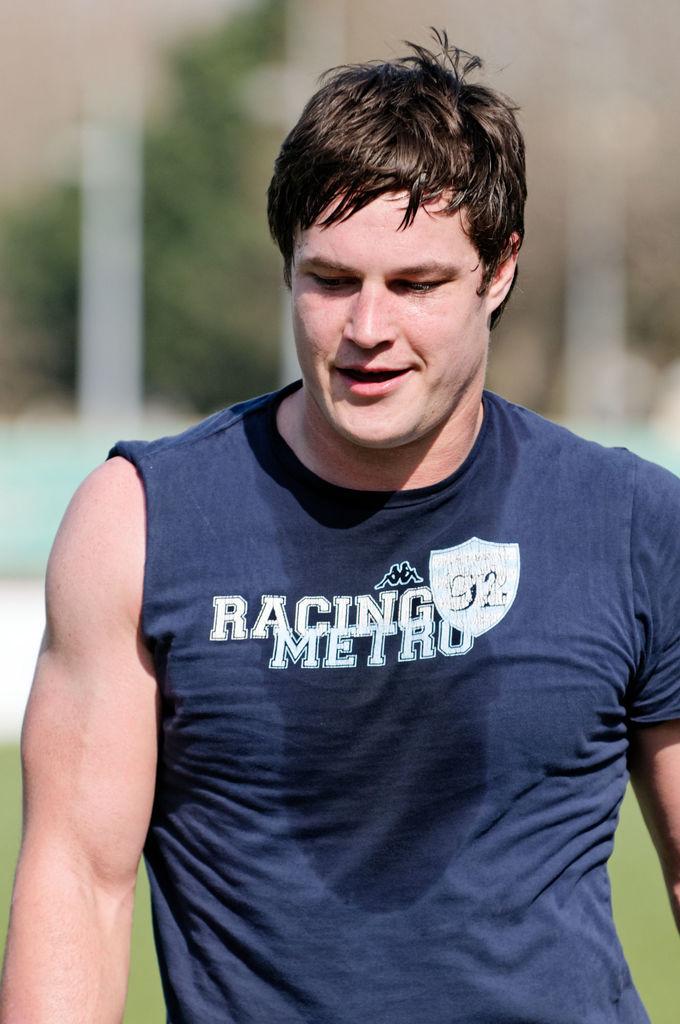What is printed on the t-shirt?
Provide a succinct answer. Racing metro. What is the name on the shirt?
Make the answer very short. Racing metro. 